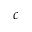<formula> <loc_0><loc_0><loc_500><loc_500>c</formula> 